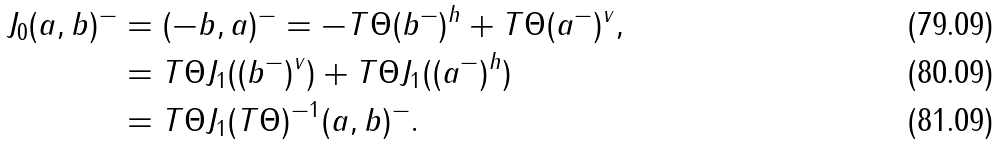Convert formula to latex. <formula><loc_0><loc_0><loc_500><loc_500>J _ { 0 } ( a , b ) ^ { - } & = ( - b , a ) ^ { - } = - T \Theta ( b ^ { - } ) ^ { h } + T \Theta ( a ^ { - } ) ^ { v } , \\ & = T \Theta J _ { 1 } ( ( b ^ { - } ) ^ { v } ) + T \Theta J _ { 1 } ( ( a ^ { - } ) ^ { h } ) \\ & = T \Theta J _ { 1 } ( T \Theta ) ^ { - 1 } ( a , b ) ^ { - } .</formula> 